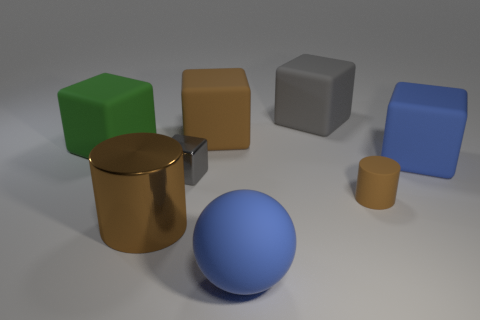There is another cylinder that is the same color as the matte cylinder; what is it made of?
Keep it short and to the point. Metal. How many rubber objects are behind the big green block?
Make the answer very short. 2. There is a thing that is in front of the big brown cylinder; does it have the same color as the rubber cube that is in front of the large green cube?
Offer a terse response. Yes. What is the color of the other shiny thing that is the same shape as the large gray object?
Provide a succinct answer. Gray. There is a big object that is to the right of the gray rubber thing; is it the same shape as the brown matte object that is to the right of the rubber sphere?
Make the answer very short. No. Does the brown matte block have the same size as the brown rubber thing right of the large gray matte block?
Your answer should be compact. No. Is the number of yellow spheres greater than the number of rubber spheres?
Provide a short and direct response. No. Are the gray thing that is to the left of the rubber ball and the cylinder that is on the left side of the large brown cube made of the same material?
Your answer should be very brief. Yes. What is the material of the big ball?
Give a very brief answer. Rubber. Are there more shiny things to the right of the large blue block than tiny gray metal things?
Offer a terse response. No. 